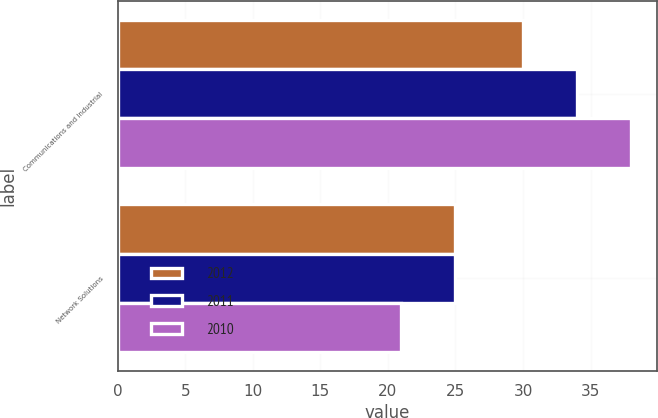Convert chart. <chart><loc_0><loc_0><loc_500><loc_500><stacked_bar_chart><ecel><fcel>Communications and Industrial<fcel>Network Solutions<nl><fcel>2012<fcel>30<fcel>25<nl><fcel>2011<fcel>34<fcel>25<nl><fcel>2010<fcel>38<fcel>21<nl></chart> 